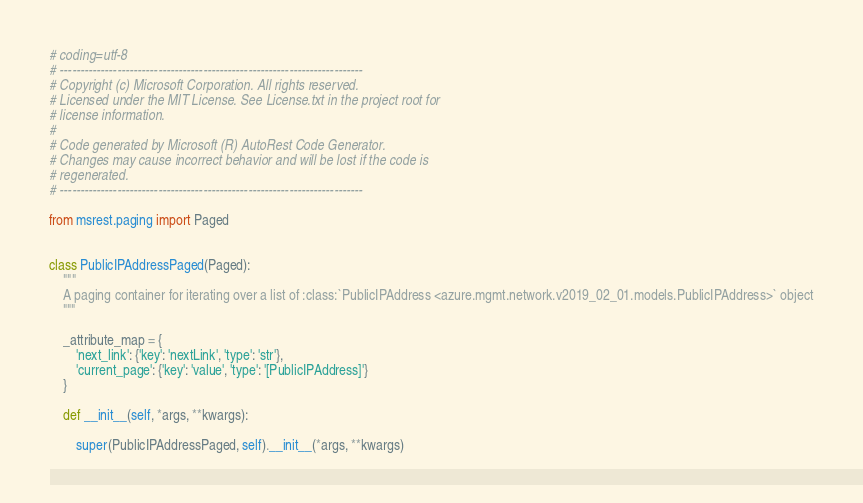Convert code to text. <code><loc_0><loc_0><loc_500><loc_500><_Python_># coding=utf-8
# --------------------------------------------------------------------------
# Copyright (c) Microsoft Corporation. All rights reserved.
# Licensed under the MIT License. See License.txt in the project root for
# license information.
#
# Code generated by Microsoft (R) AutoRest Code Generator.
# Changes may cause incorrect behavior and will be lost if the code is
# regenerated.
# --------------------------------------------------------------------------

from msrest.paging import Paged


class PublicIPAddressPaged(Paged):
    """
    A paging container for iterating over a list of :class:`PublicIPAddress <azure.mgmt.network.v2019_02_01.models.PublicIPAddress>` object
    """

    _attribute_map = {
        'next_link': {'key': 'nextLink', 'type': 'str'},
        'current_page': {'key': 'value', 'type': '[PublicIPAddress]'}
    }

    def __init__(self, *args, **kwargs):

        super(PublicIPAddressPaged, self).__init__(*args, **kwargs)
</code> 